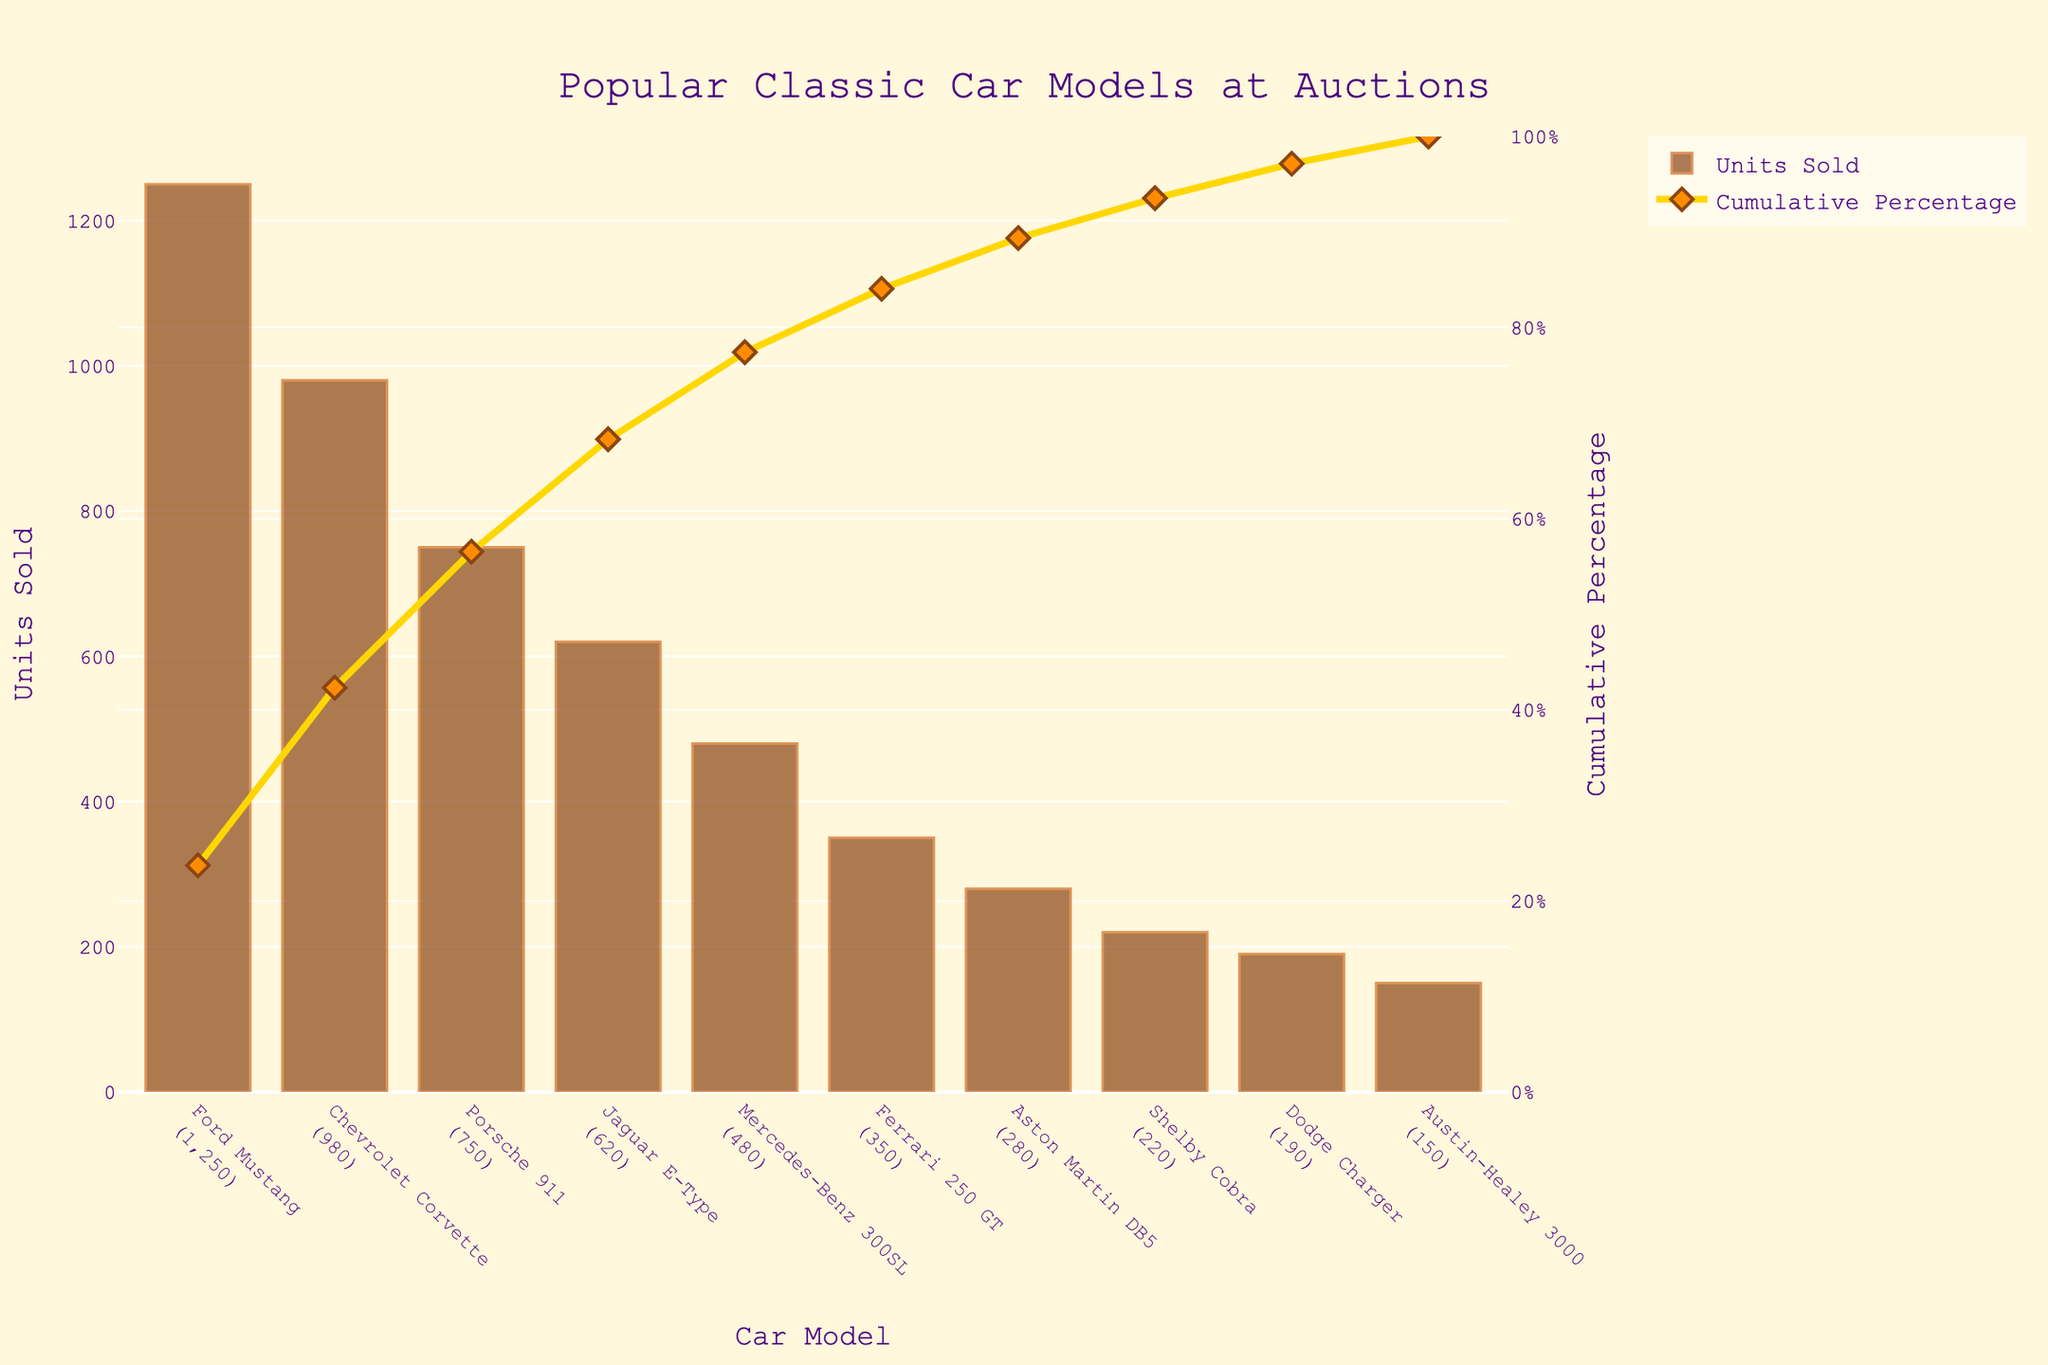what is the title of the figure? The title of the figure is displayed at the top and is styled to be prominent. It reads: "Popular Classic Car Models at Auctions".
Answer: Popular Classic Car Models at Auctions What is the total number of classic car models shown in the figure? Each bar in the chart represents a classic car model and there are 10 bars in total.
Answer: 10 Which car model has the highest sales volume? The bar corresponding to the Ford Mustang is the tallest, indicating it has the highest sales volume.
Answer: Ford Mustang What is the cumulative percentage of units sold for Ford Mustang and Chevrolet Corvette combined? The cumulative percentage for Ford Mustang is 28.73%. Adding this to the percentage for Chevrolet Corvette, which is 50.24%, gives a total of 28.73% + 21.51% = 50.24%.
Answer: 50.24% Which car model has the smallest contribution to the cumulative percentage and what is its value? The Austin-Healey 3000, at the bottom of the chart, has the smallest bar and the lowest cumulative percentage. Its value is 98.92%.
Answer: Austin-Healey 3000, 1.08% What is the difference in units sold between Ford Mustang and Porsche 911? The units sold for Ford Mustang (1250) minus the units sold for Porsche 911 (750) gives a difference of 500 units.
Answer: 500 Which car models collectively contribute to over 80% of the total units sold? By examining the cumulative percentage line, the car models up to Ferrari 250 GT contribute just over 80% of the total units sold. The models are Ford Mustang, Chevrolet Corvette, Porsche 911, Jaguar E-Type, Mercedes-Benz 300SL, and Ferrari 250 GT.
Answer: Ford Mustang, Chevrolet Corvette, Porsche 911, Jaguar E-Type, Mercedes-Benz 300SL, Ferrari 250 GT What can you infer from the cumulative percentage curve about the sales distribution? The cumulative percentage curve increases steeply initially and gradually slows down, indicating that a small number of car models contribute to a large proportion of the sales volume. This is a common characteristic seen in Pareto charts.
Answer: A few car models contribute to most of the sales Which car model has a units sold value of exactly 480, and what is its cumulative percentage? By matching the units sold value of 480, we find that it corresponds to the Mercedes-Benz 300SL. Its cumulative percentage is about 77.43%.
Answer: Mercedes-Benz 300SL, 77.43% Based on the figure, how many models need to be considered to reach around 95% of the total units sold? Observing the cumulative percentage line, adding up to the Dodge Charger reaches around 96%. This includes the models Ford Mustang, Chevrolet Corvette, Porsche 911, Jaguar E-Type, Mercedes-Benz 300SL, Ferrari 250 GT, Aston Martin DB5, Shelby Cobra, and Dodge Charger, totaling nine models.
Answer: 9 